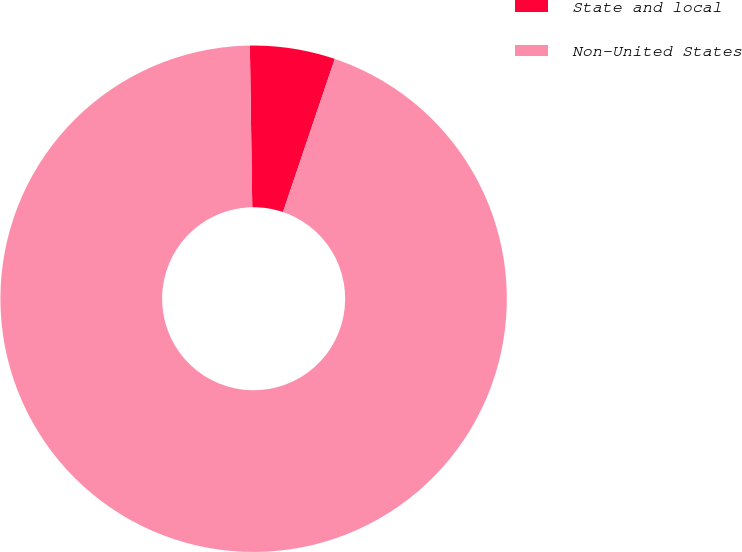Convert chart. <chart><loc_0><loc_0><loc_500><loc_500><pie_chart><fcel>State and local<fcel>Non-United States<nl><fcel>5.43%<fcel>94.57%<nl></chart> 